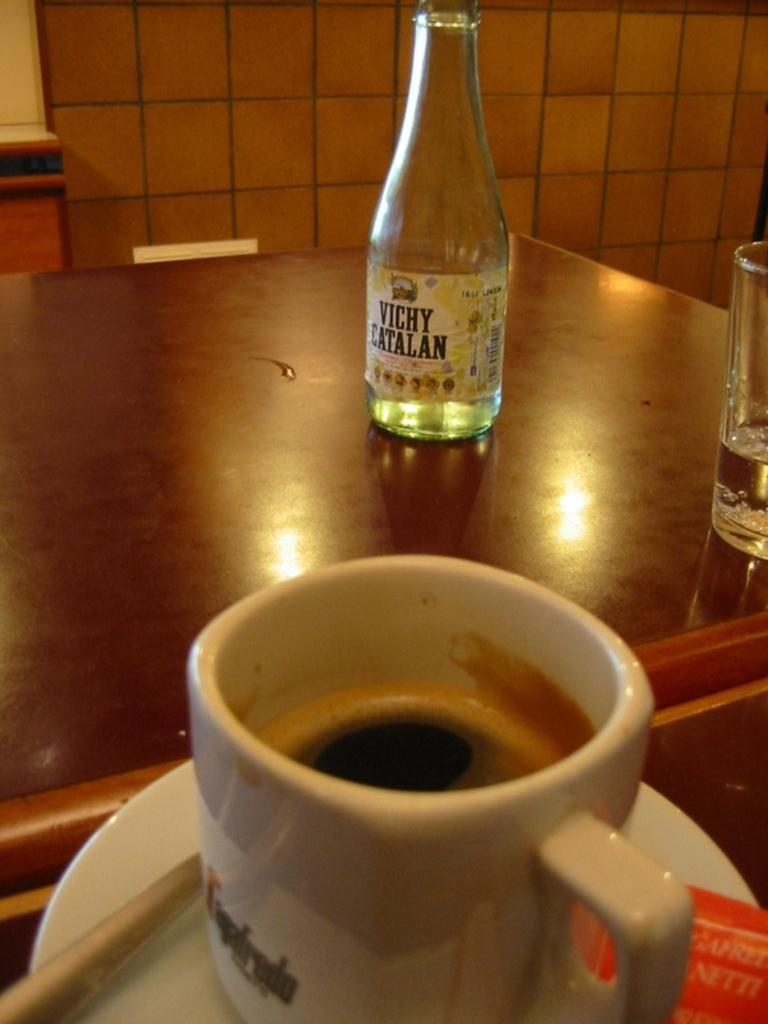<image>
Offer a succinct explanation of the picture presented. a bottle of vichy catalan standing on an almost empty table 